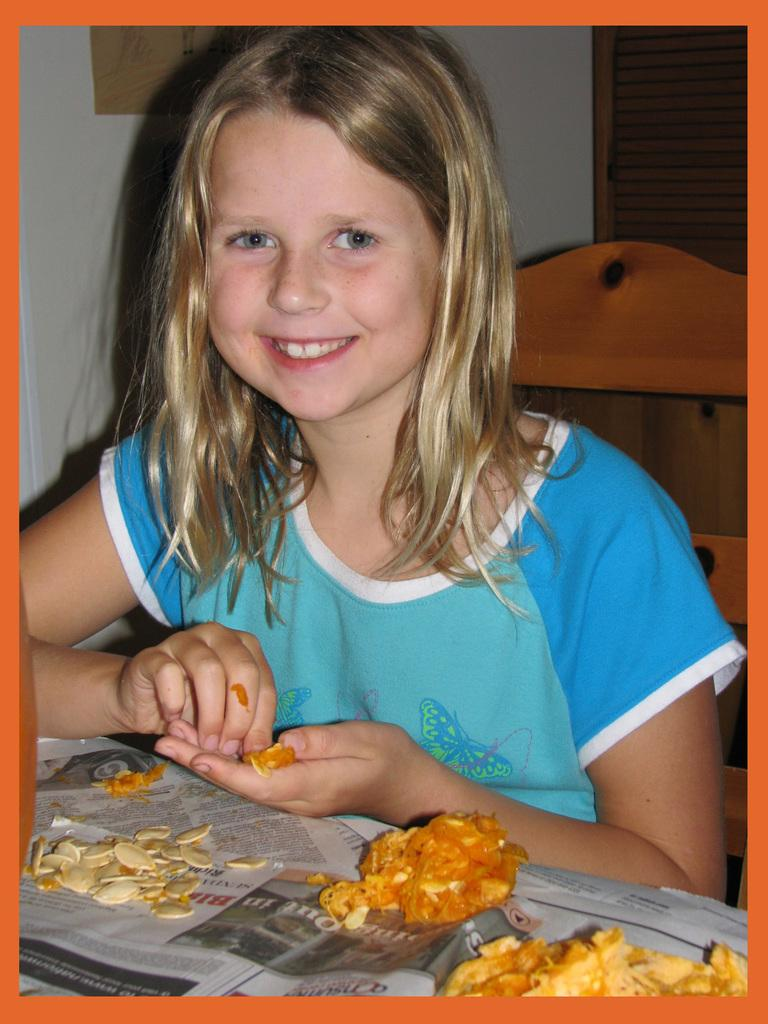Who is present in the image? There is a girl in the image. What is the girl's expression? The girl is smiling. What is in front of the girl? There is food and newspapers in front of the girl. What can be seen in the background of the image? There is a wall and objects visible in the background of the image. What type of flower is the girl holding in the image? There is no flower present in the image; the girl is not holding anything. 